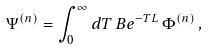<formula> <loc_0><loc_0><loc_500><loc_500>\Psi ^ { ( n ) } = \int _ { 0 } ^ { \infty } d T \, B e ^ { - T L } \, \Phi ^ { ( n ) } \, ,</formula> 